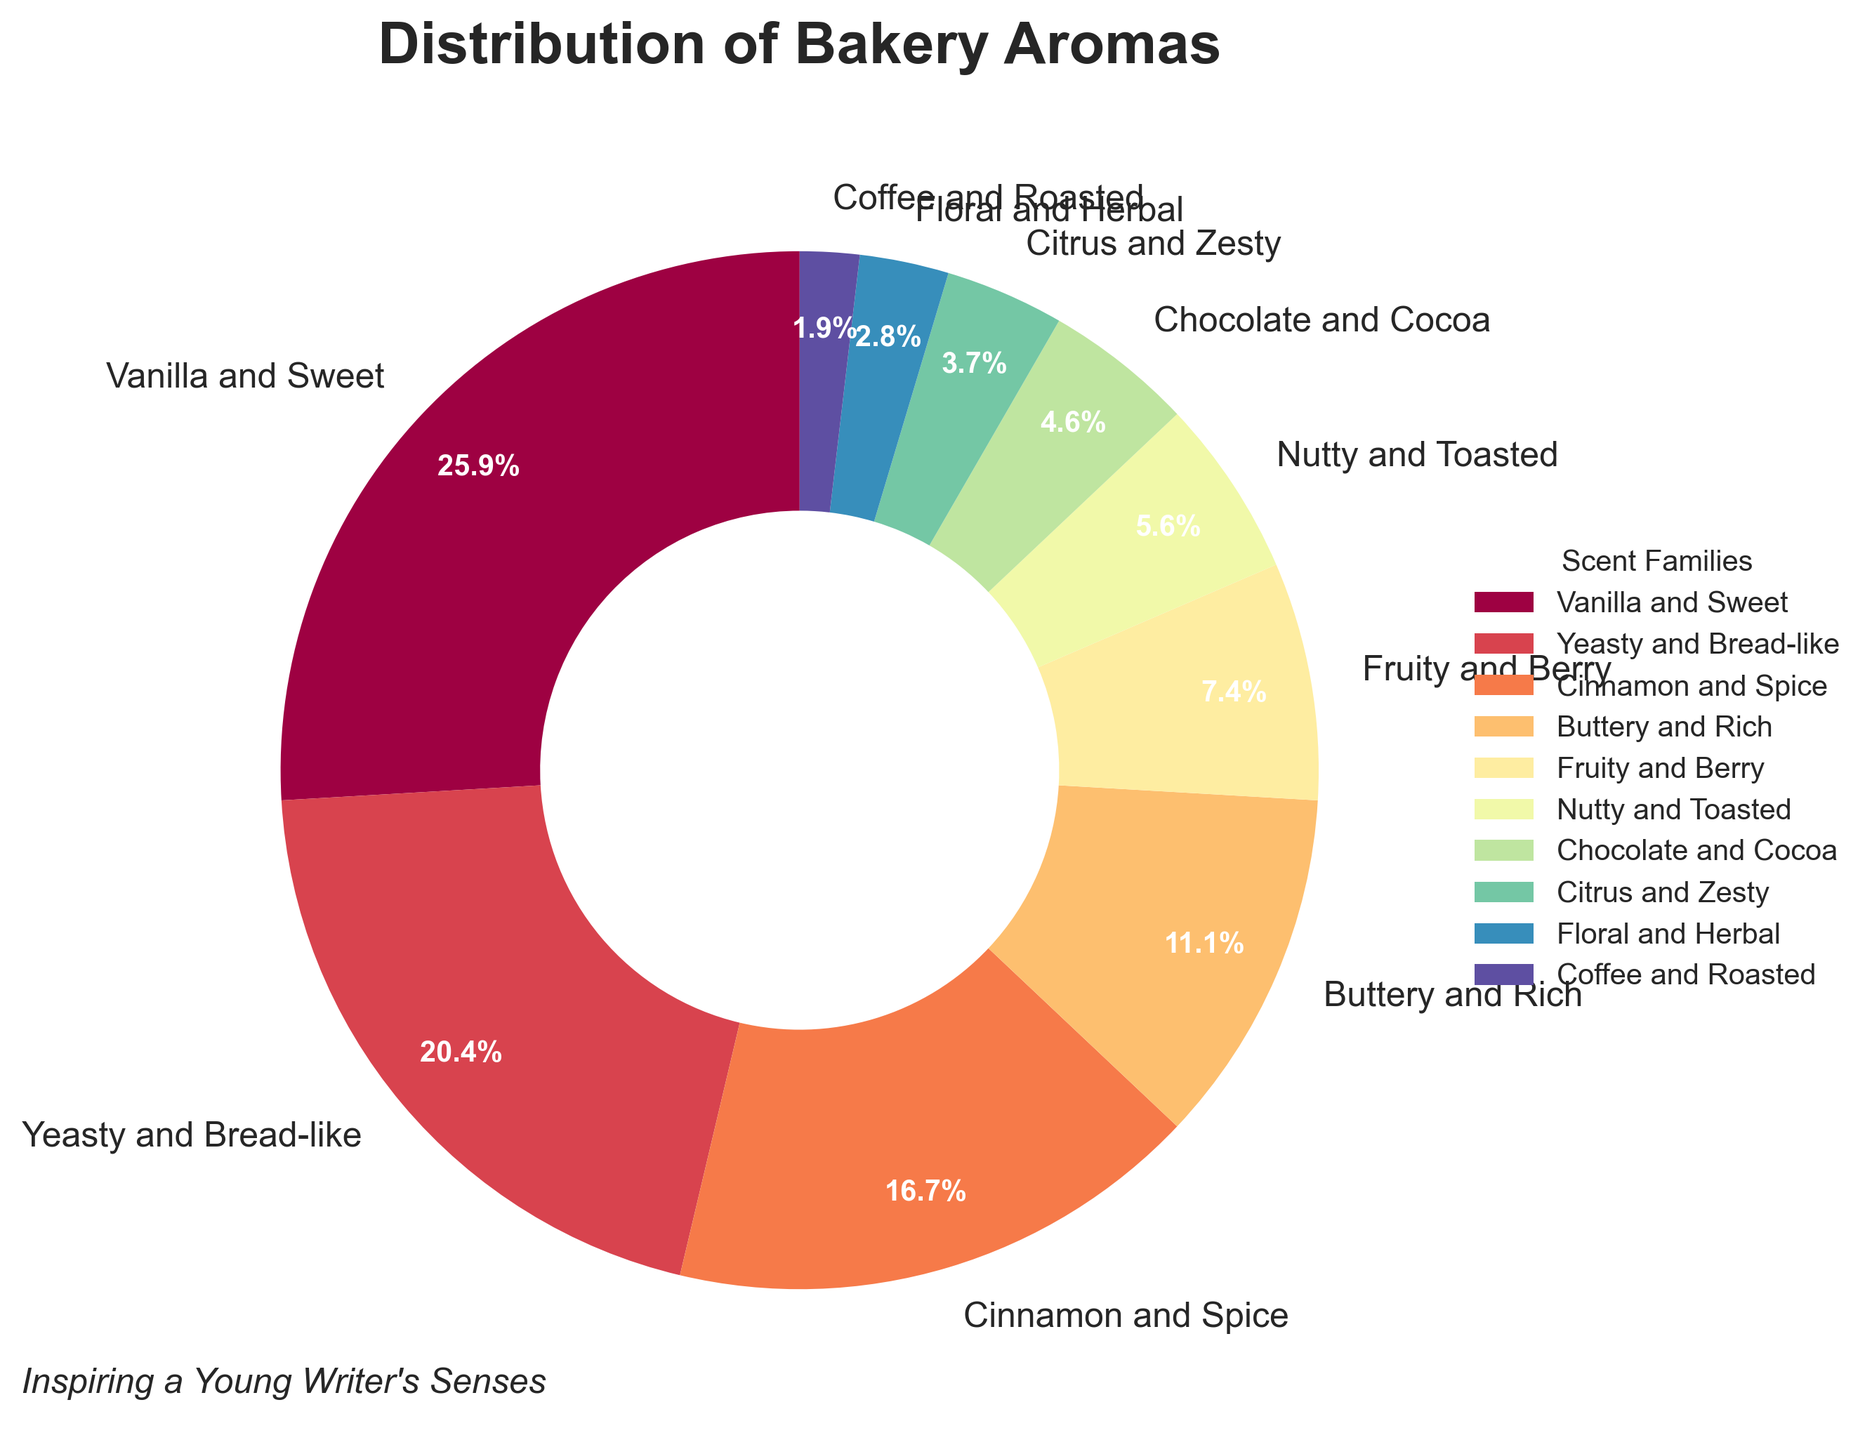What scent family has the largest percentage of bakery aromas? The pie chart lists 'Vanilla and Sweet' as having the largest wedge and therefore the largest percentage at 28%.
Answer: Vanilla and Sweet Which scent family has a percentage of aromas closest to the average percentage? To find the closest to the average, first calculate the average percentage over all scent families. The average is (28 + 22 + 18 + 12 + 8 + 6 + 5 + 4 + 3 + 2) / 10 = 10.8%. The 'Buttery and Rich' scent family, with 12%, is closest to this average.
Answer: Buttery and Rich What is the combined percentage of 'Yeasty and Bread-like' and 'Cinnamon and Spice' scent families? Add the percentages for these families: 22% (Yeasty and Bread-like) + 18% (Cinnamon and Spice) = 40%.
Answer: 40% What is the difference in percentage between the 'Fruity and Berry' and 'Chocolate and Cocoa' scent families? Subtract the percentage for 'Chocolate and Cocoa' from the percentage for 'Fruity and Berry': 8% - 5% = 3%.
Answer: 3% Identify the scent families that together make up less than 10% of the bakery aromas. The scent families with percentages adding up to less than 10% are 'Coffee and Roasted' (2%), and 'Floral and Herbal' (3%), totaling 5%.
Answer: Coffee and Roasted, Floral and Herbal Which scent family segment appears in red color, and what is its percentage? By referring to the visual attributes of the pie chart, the segment colored red represents 'Yeasty and Bread-like,' which has a percentage of 22%.
Answer: Yeasty and Bread-like, 22% If the 'Vanilla and Sweet' aroma inspires 40% more customers next year, what will its new percentage be? Increase the current percentage by 40%. Calculate 40% of 28%: 28 × 0.40 = 11.2%. Add this to the current percentage: 28% + 11.2% = 39.2%.
Answer: 39.2% What scent family contributes the second least to the distribution of bakery aromas? By examining the sizes of the slices, the 'Coffee and Roasted' scent family, at 2%, is the second least contributor, with only 'Floral and Herbal' contributing less at 3%.
Answer: Coffee and Roasted 